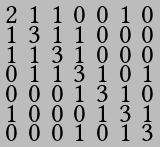<formula> <loc_0><loc_0><loc_500><loc_500>\begin{smallmatrix} 2 & 1 & 1 & 0 & 0 & 1 & 0 \\ 1 & 3 & 1 & 1 & 0 & 0 & 0 \\ 1 & 1 & 3 & 1 & 0 & 0 & 0 \\ 0 & 1 & 1 & 3 & 1 & 0 & 1 \\ 0 & 0 & 0 & 1 & 3 & 1 & 0 \\ 1 & 0 & 0 & 0 & 1 & 3 & 1 \\ 0 & 0 & 0 & 1 & 0 & 1 & 3 \end{smallmatrix}</formula> 